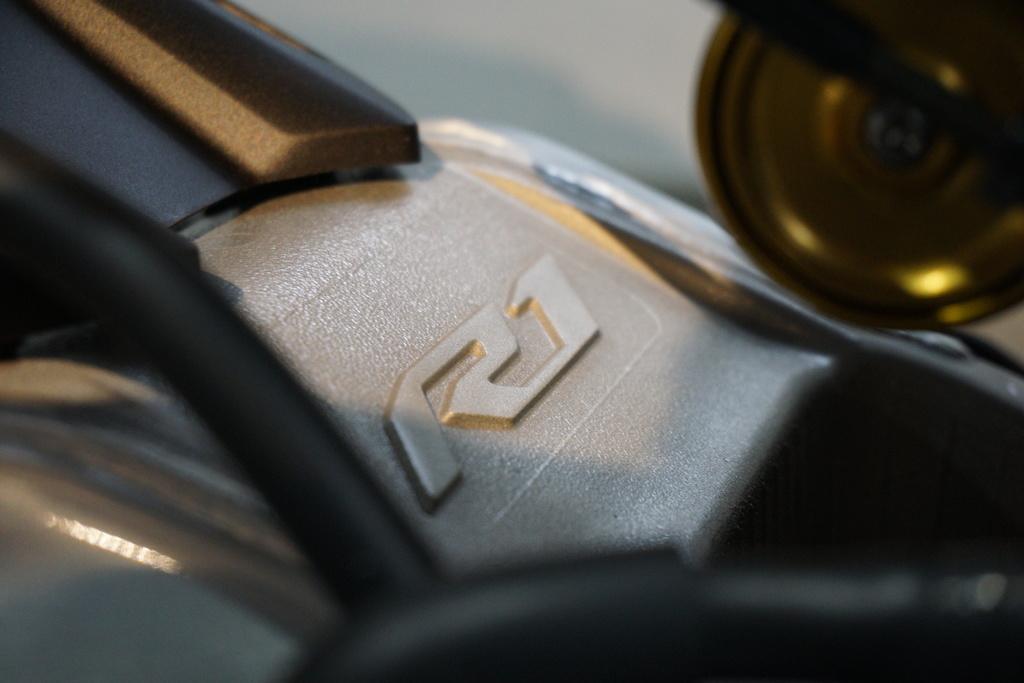Describe this image in one or two sentences. In this image I can see the zoom in picture in which I can see an object which is brown, black and cream in color. 